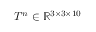Convert formula to latex. <formula><loc_0><loc_0><loc_500><loc_500>T ^ { n } \in \mathbb { R } ^ { 3 \times 3 \times 1 0 }</formula> 